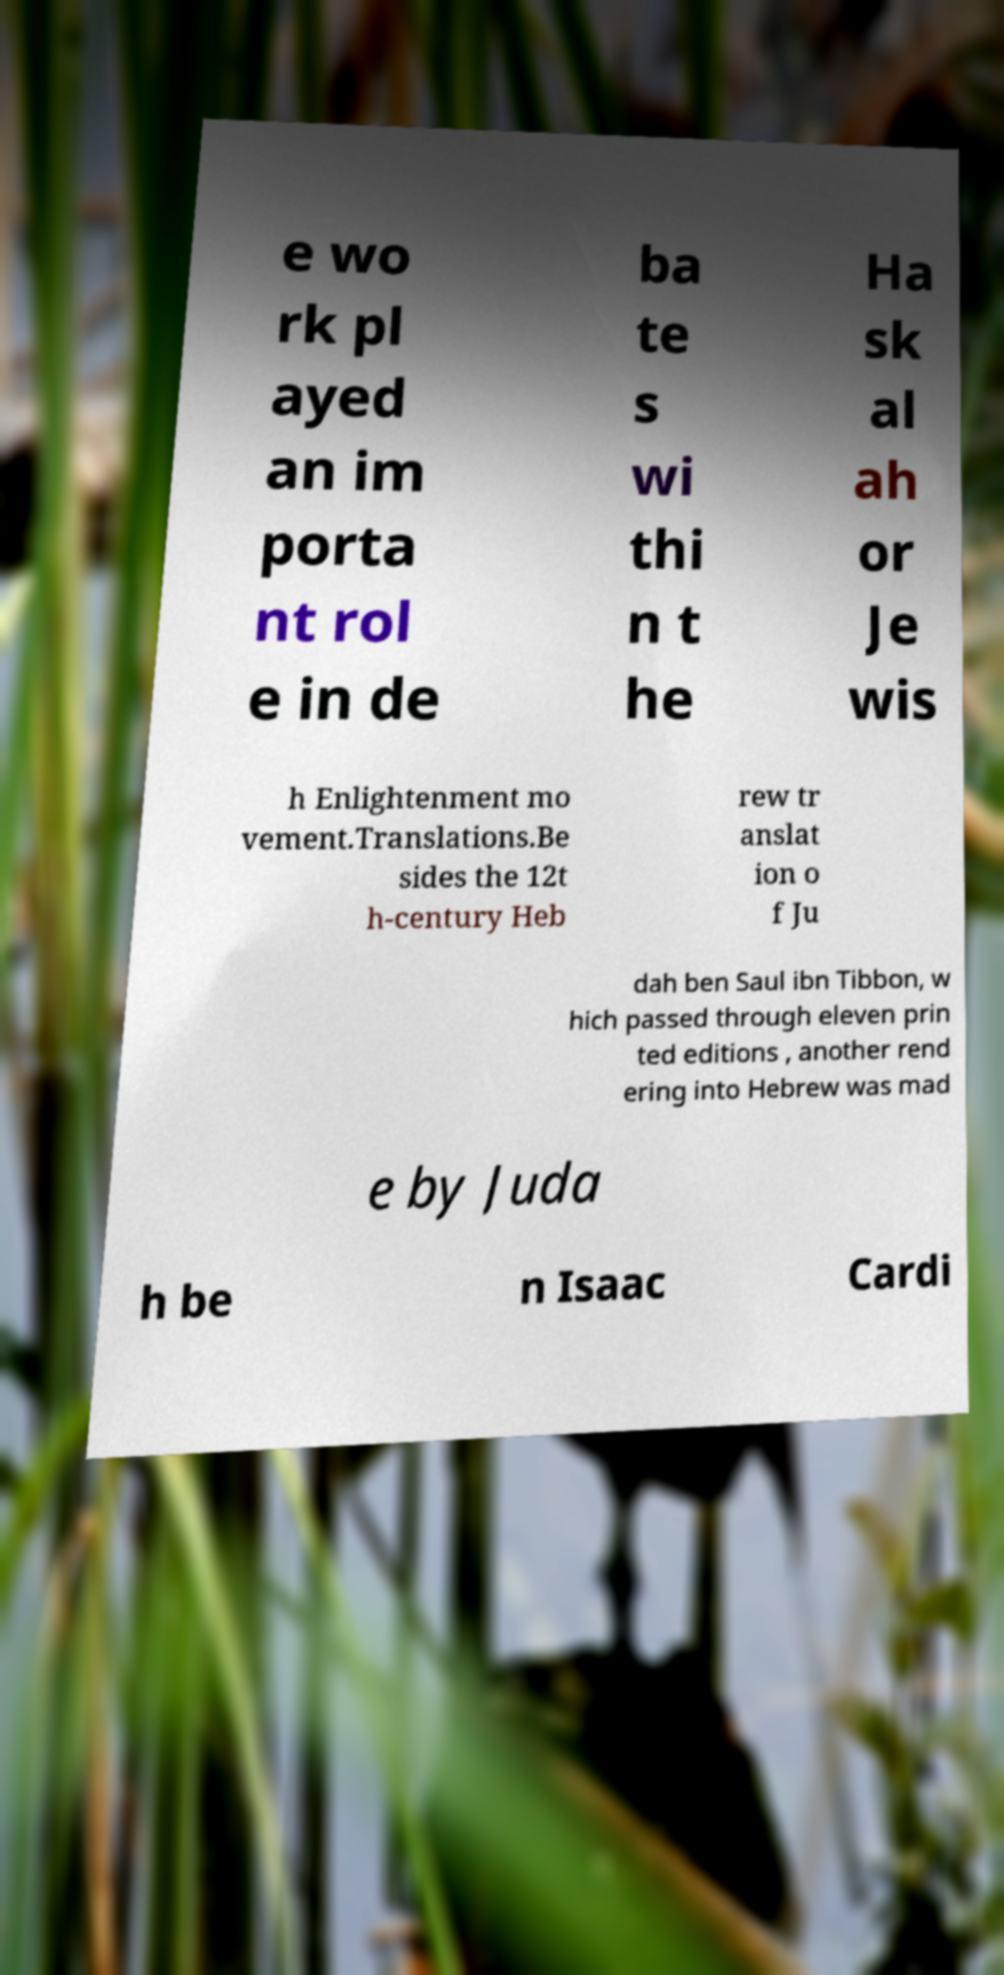Could you extract and type out the text from this image? e wo rk pl ayed an im porta nt rol e in de ba te s wi thi n t he Ha sk al ah or Je wis h Enlightenment mo vement.Translations.Be sides the 12t h-century Heb rew tr anslat ion o f Ju dah ben Saul ibn Tibbon, w hich passed through eleven prin ted editions , another rend ering into Hebrew was mad e by Juda h be n Isaac Cardi 